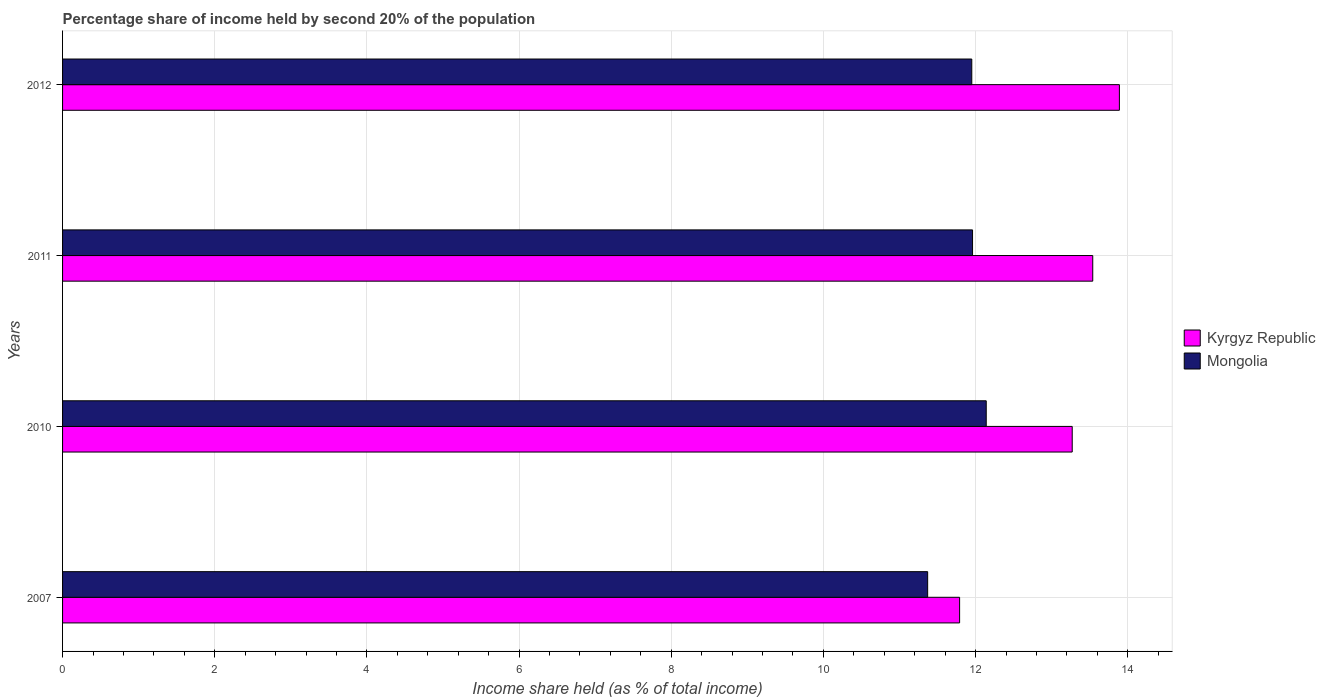How many different coloured bars are there?
Offer a terse response. 2. How many groups of bars are there?
Give a very brief answer. 4. Are the number of bars on each tick of the Y-axis equal?
Your answer should be compact. Yes. How many bars are there on the 1st tick from the bottom?
Keep it short and to the point. 2. What is the share of income held by second 20% of the population in Mongolia in 2007?
Provide a short and direct response. 11.37. Across all years, what is the maximum share of income held by second 20% of the population in Mongolia?
Your response must be concise. 12.14. Across all years, what is the minimum share of income held by second 20% of the population in Mongolia?
Your answer should be very brief. 11.37. What is the total share of income held by second 20% of the population in Kyrgyz Republic in the graph?
Provide a short and direct response. 52.49. What is the difference between the share of income held by second 20% of the population in Kyrgyz Republic in 2007 and that in 2011?
Give a very brief answer. -1.75. What is the difference between the share of income held by second 20% of the population in Kyrgyz Republic in 2011 and the share of income held by second 20% of the population in Mongolia in 2012?
Keep it short and to the point. 1.59. What is the average share of income held by second 20% of the population in Mongolia per year?
Offer a terse response. 11.86. In the year 2012, what is the difference between the share of income held by second 20% of the population in Kyrgyz Republic and share of income held by second 20% of the population in Mongolia?
Make the answer very short. 1.94. In how many years, is the share of income held by second 20% of the population in Mongolia greater than 4.4 %?
Ensure brevity in your answer.  4. What is the ratio of the share of income held by second 20% of the population in Kyrgyz Republic in 2010 to that in 2012?
Provide a short and direct response. 0.96. What is the difference between the highest and the second highest share of income held by second 20% of the population in Mongolia?
Provide a short and direct response. 0.18. What is the difference between the highest and the lowest share of income held by second 20% of the population in Kyrgyz Republic?
Make the answer very short. 2.1. What does the 2nd bar from the top in 2010 represents?
Offer a very short reply. Kyrgyz Republic. What does the 2nd bar from the bottom in 2011 represents?
Give a very brief answer. Mongolia. Are all the bars in the graph horizontal?
Make the answer very short. Yes. Are the values on the major ticks of X-axis written in scientific E-notation?
Provide a short and direct response. No. Does the graph contain any zero values?
Ensure brevity in your answer.  No. Where does the legend appear in the graph?
Offer a terse response. Center right. How many legend labels are there?
Keep it short and to the point. 2. How are the legend labels stacked?
Keep it short and to the point. Vertical. What is the title of the graph?
Provide a short and direct response. Percentage share of income held by second 20% of the population. What is the label or title of the X-axis?
Offer a terse response. Income share held (as % of total income). What is the label or title of the Y-axis?
Keep it short and to the point. Years. What is the Income share held (as % of total income) in Kyrgyz Republic in 2007?
Your answer should be compact. 11.79. What is the Income share held (as % of total income) of Mongolia in 2007?
Provide a succinct answer. 11.37. What is the Income share held (as % of total income) of Kyrgyz Republic in 2010?
Give a very brief answer. 13.27. What is the Income share held (as % of total income) in Mongolia in 2010?
Offer a terse response. 12.14. What is the Income share held (as % of total income) in Kyrgyz Republic in 2011?
Offer a very short reply. 13.54. What is the Income share held (as % of total income) in Mongolia in 2011?
Make the answer very short. 11.96. What is the Income share held (as % of total income) of Kyrgyz Republic in 2012?
Keep it short and to the point. 13.89. What is the Income share held (as % of total income) in Mongolia in 2012?
Your response must be concise. 11.95. Across all years, what is the maximum Income share held (as % of total income) in Kyrgyz Republic?
Keep it short and to the point. 13.89. Across all years, what is the maximum Income share held (as % of total income) of Mongolia?
Your response must be concise. 12.14. Across all years, what is the minimum Income share held (as % of total income) of Kyrgyz Republic?
Offer a very short reply. 11.79. Across all years, what is the minimum Income share held (as % of total income) of Mongolia?
Offer a terse response. 11.37. What is the total Income share held (as % of total income) in Kyrgyz Republic in the graph?
Provide a short and direct response. 52.49. What is the total Income share held (as % of total income) in Mongolia in the graph?
Ensure brevity in your answer.  47.42. What is the difference between the Income share held (as % of total income) in Kyrgyz Republic in 2007 and that in 2010?
Offer a very short reply. -1.48. What is the difference between the Income share held (as % of total income) in Mongolia in 2007 and that in 2010?
Offer a terse response. -0.77. What is the difference between the Income share held (as % of total income) in Kyrgyz Republic in 2007 and that in 2011?
Your answer should be very brief. -1.75. What is the difference between the Income share held (as % of total income) of Mongolia in 2007 and that in 2011?
Your response must be concise. -0.59. What is the difference between the Income share held (as % of total income) in Mongolia in 2007 and that in 2012?
Ensure brevity in your answer.  -0.58. What is the difference between the Income share held (as % of total income) of Kyrgyz Republic in 2010 and that in 2011?
Offer a terse response. -0.27. What is the difference between the Income share held (as % of total income) in Mongolia in 2010 and that in 2011?
Offer a terse response. 0.18. What is the difference between the Income share held (as % of total income) of Kyrgyz Republic in 2010 and that in 2012?
Offer a very short reply. -0.62. What is the difference between the Income share held (as % of total income) in Mongolia in 2010 and that in 2012?
Provide a succinct answer. 0.19. What is the difference between the Income share held (as % of total income) in Kyrgyz Republic in 2011 and that in 2012?
Make the answer very short. -0.35. What is the difference between the Income share held (as % of total income) in Mongolia in 2011 and that in 2012?
Your answer should be compact. 0.01. What is the difference between the Income share held (as % of total income) of Kyrgyz Republic in 2007 and the Income share held (as % of total income) of Mongolia in 2010?
Keep it short and to the point. -0.35. What is the difference between the Income share held (as % of total income) in Kyrgyz Republic in 2007 and the Income share held (as % of total income) in Mongolia in 2011?
Your answer should be compact. -0.17. What is the difference between the Income share held (as % of total income) in Kyrgyz Republic in 2007 and the Income share held (as % of total income) in Mongolia in 2012?
Your answer should be very brief. -0.16. What is the difference between the Income share held (as % of total income) of Kyrgyz Republic in 2010 and the Income share held (as % of total income) of Mongolia in 2011?
Your response must be concise. 1.31. What is the difference between the Income share held (as % of total income) in Kyrgyz Republic in 2010 and the Income share held (as % of total income) in Mongolia in 2012?
Give a very brief answer. 1.32. What is the difference between the Income share held (as % of total income) in Kyrgyz Republic in 2011 and the Income share held (as % of total income) in Mongolia in 2012?
Provide a short and direct response. 1.59. What is the average Income share held (as % of total income) of Kyrgyz Republic per year?
Keep it short and to the point. 13.12. What is the average Income share held (as % of total income) in Mongolia per year?
Offer a very short reply. 11.86. In the year 2007, what is the difference between the Income share held (as % of total income) of Kyrgyz Republic and Income share held (as % of total income) of Mongolia?
Keep it short and to the point. 0.42. In the year 2010, what is the difference between the Income share held (as % of total income) of Kyrgyz Republic and Income share held (as % of total income) of Mongolia?
Provide a short and direct response. 1.13. In the year 2011, what is the difference between the Income share held (as % of total income) of Kyrgyz Republic and Income share held (as % of total income) of Mongolia?
Keep it short and to the point. 1.58. In the year 2012, what is the difference between the Income share held (as % of total income) of Kyrgyz Republic and Income share held (as % of total income) of Mongolia?
Ensure brevity in your answer.  1.94. What is the ratio of the Income share held (as % of total income) in Kyrgyz Republic in 2007 to that in 2010?
Provide a short and direct response. 0.89. What is the ratio of the Income share held (as % of total income) in Mongolia in 2007 to that in 2010?
Keep it short and to the point. 0.94. What is the ratio of the Income share held (as % of total income) in Kyrgyz Republic in 2007 to that in 2011?
Your answer should be compact. 0.87. What is the ratio of the Income share held (as % of total income) in Mongolia in 2007 to that in 2011?
Your answer should be very brief. 0.95. What is the ratio of the Income share held (as % of total income) of Kyrgyz Republic in 2007 to that in 2012?
Ensure brevity in your answer.  0.85. What is the ratio of the Income share held (as % of total income) in Mongolia in 2007 to that in 2012?
Keep it short and to the point. 0.95. What is the ratio of the Income share held (as % of total income) in Kyrgyz Republic in 2010 to that in 2011?
Your answer should be compact. 0.98. What is the ratio of the Income share held (as % of total income) in Mongolia in 2010 to that in 2011?
Your answer should be compact. 1.02. What is the ratio of the Income share held (as % of total income) in Kyrgyz Republic in 2010 to that in 2012?
Your answer should be very brief. 0.96. What is the ratio of the Income share held (as % of total income) in Mongolia in 2010 to that in 2012?
Provide a succinct answer. 1.02. What is the ratio of the Income share held (as % of total income) in Kyrgyz Republic in 2011 to that in 2012?
Provide a short and direct response. 0.97. What is the ratio of the Income share held (as % of total income) of Mongolia in 2011 to that in 2012?
Make the answer very short. 1. What is the difference between the highest and the second highest Income share held (as % of total income) of Mongolia?
Offer a very short reply. 0.18. What is the difference between the highest and the lowest Income share held (as % of total income) of Kyrgyz Republic?
Make the answer very short. 2.1. What is the difference between the highest and the lowest Income share held (as % of total income) of Mongolia?
Provide a succinct answer. 0.77. 